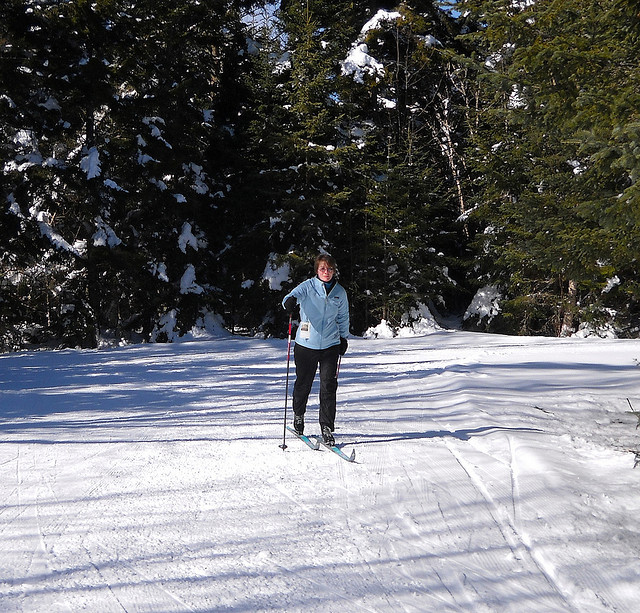What winter activity is the person in the image engaged in? The person in the image appears to be cross-country skiing, a popular winter sport that involves gliding across snow-covered terrain using skis and poles. What kind of gear is necessary for this activity? For cross-country skiing, one generally needs skis, poles, boots that are connected to the skis using bindings, and appropriate cold-weather clothing to stay warm and mobile. 